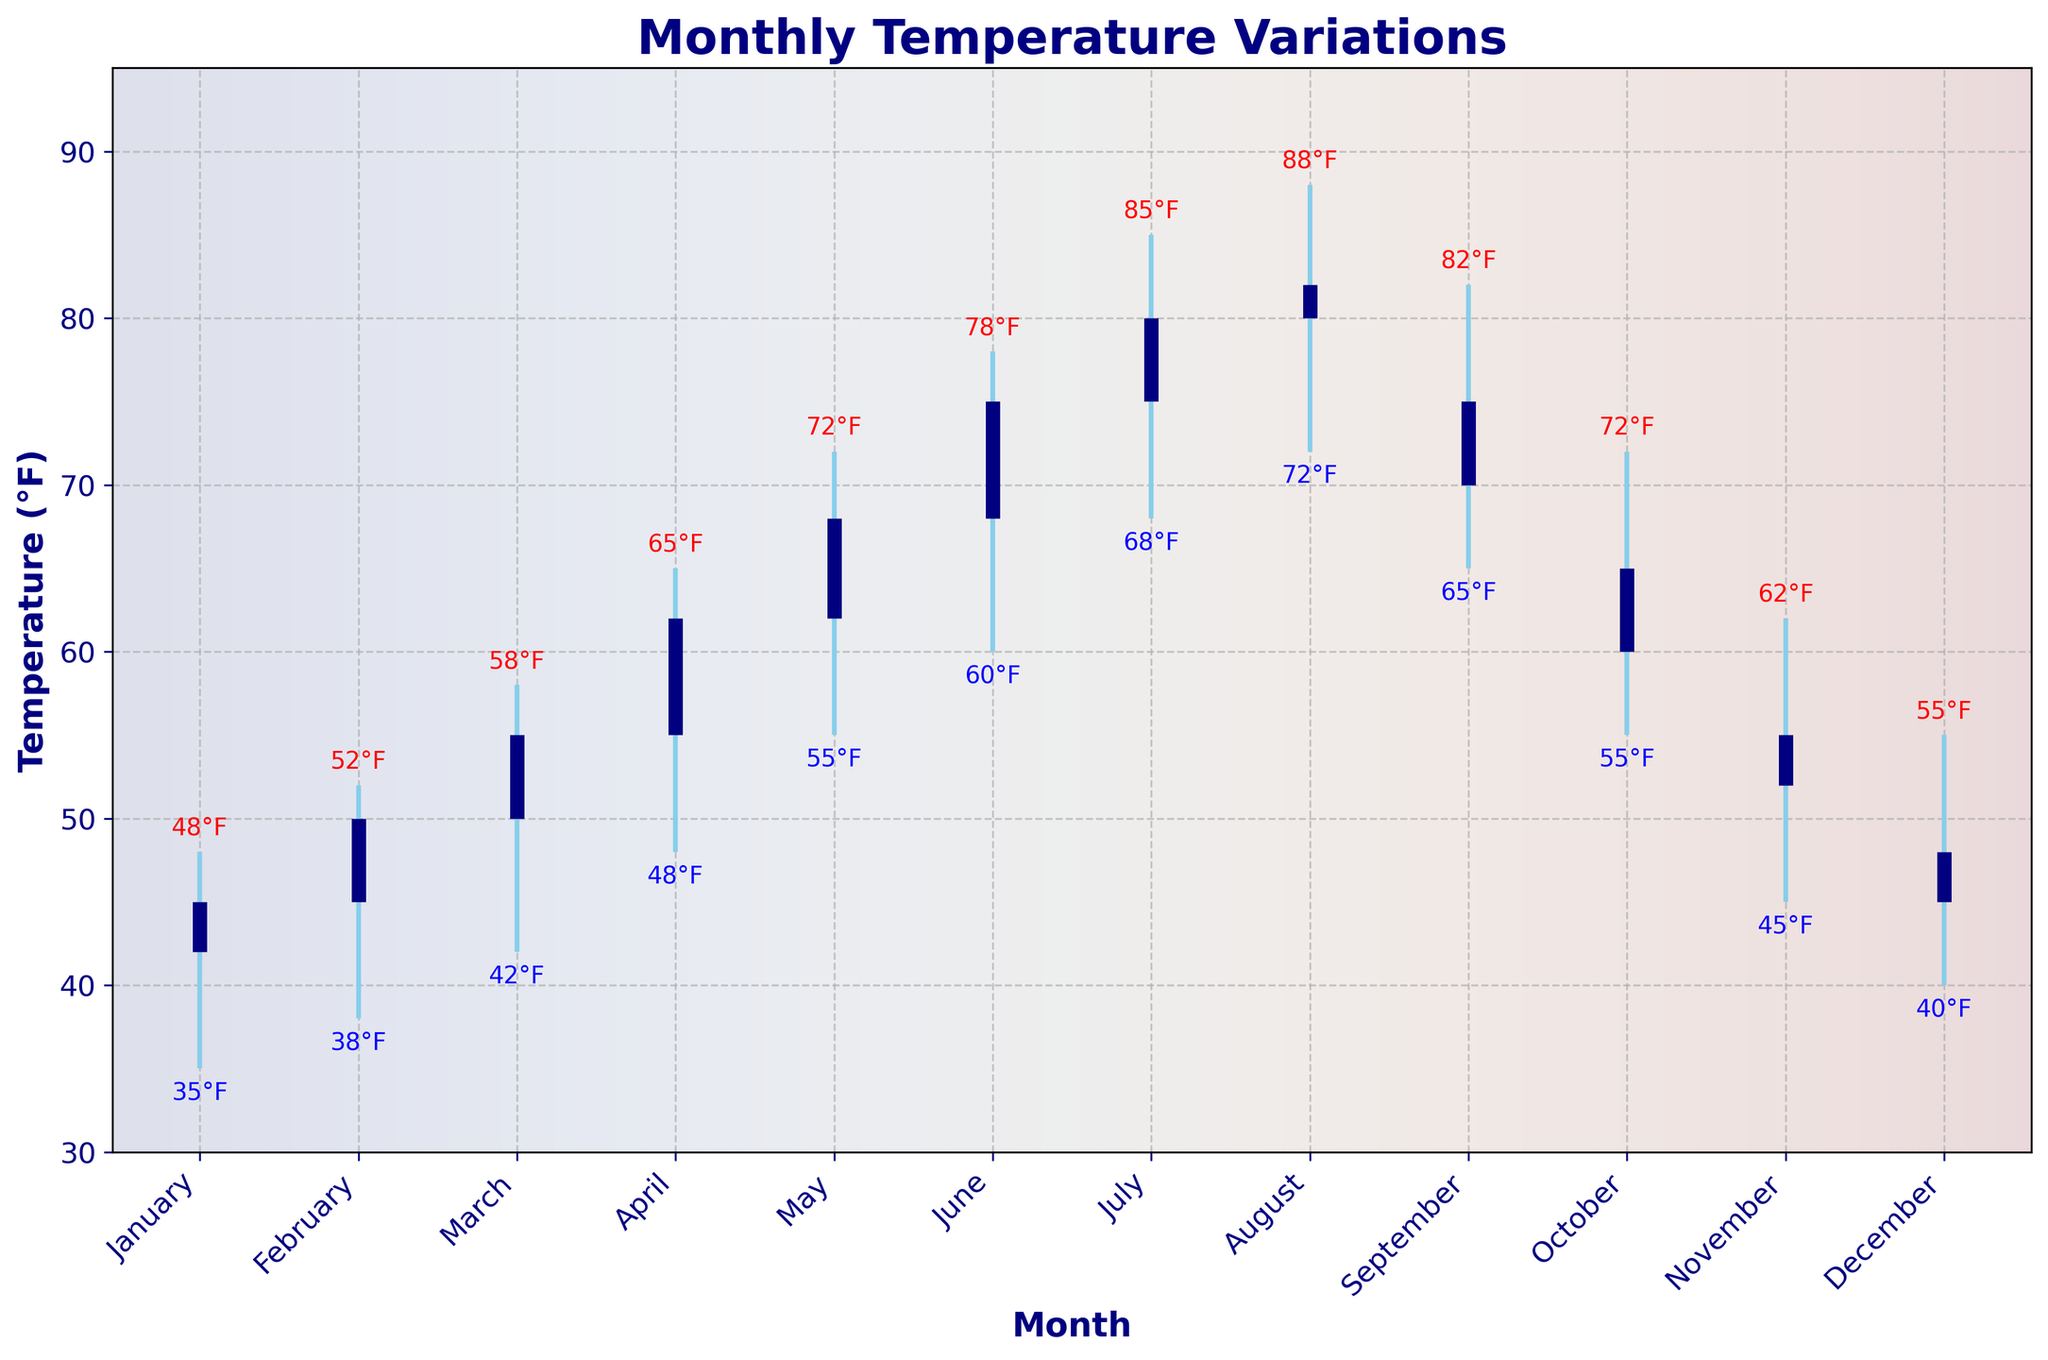what's the title of the figure? The title of the figure is displayed on top in bold and larger font.
Answer: Monthly Temperature Variations which month shows the highest temperature? The highest temperature is indicated by the top point of the vertical line; for August, the high is 88°F, which is the highest.
Answer: August what are the highest and lowest temperatures recorded in March? Identify the high and low points of the vertical line for March. The high is 58°F, and the low is 42°F.
Answer: High: 58°F, Low: 42°F which month has the biggest difference between high and low temperatures? Calculate the difference between high and low for each month. May has the largest difference (72 - 55 = 17°F).
Answer: May compare the temperatures in July and December. Which month is warmer? Compare the high, low, open, and close values for July and December. July’s temperatures (85°F, 75°F, 68°F, 80°F) are much higher than December’s (55°F, 48°F, 40°F, 45°F).
Answer: July what trend can you observe from January to June in terms of temperature changes? Look at the open, high, low, and close points from January to June; all show a general increase each month.
Answer: Increasing trend in which months did the closing temperature equal the opening temperature? Identify months where the open and close values are the same. January and October both have the same open and close values (45°F and 60°F respectively).
Answer: January, October what is the average high temperature from the dataset? Sum the high values (48, 52, 58, 65, 72, 78, 85, 88, 82, 72, 62, 55) and divide by the number of months (12). (48+52+58+65+72+78+85+88+82+72+62+55) / 12 = 67.08°F
Answer: 67.08°F how many months experienced a low temperature under 40°F? Count the number of low values below 40°F (January with 35°F, February with 38°F).
Answer: 2 months 